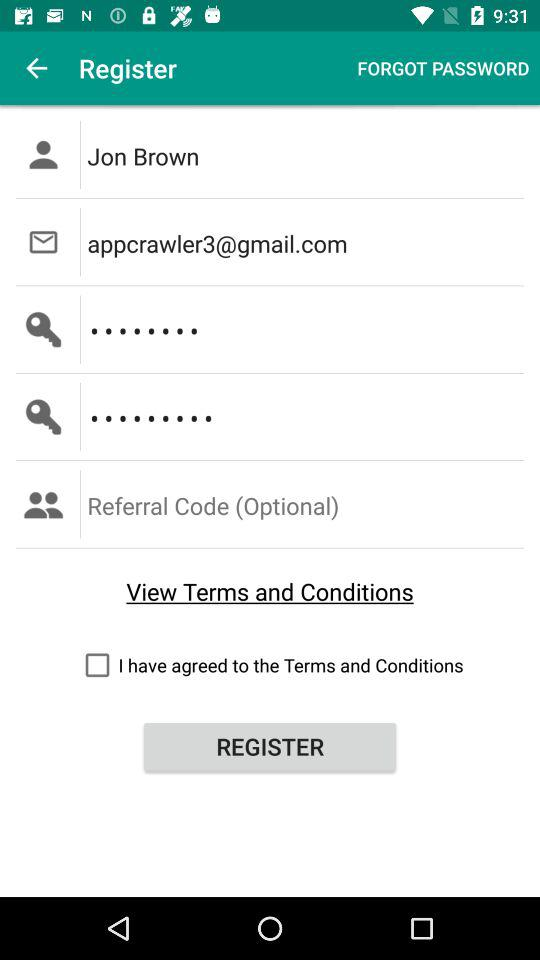What is the email address? The email address is appcrawler3@gmail.com. 